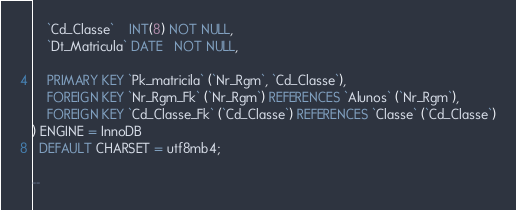<code> <loc_0><loc_0><loc_500><loc_500><_SQL_>    `Cd_Classe`    INT(8) NOT NULL,
    `Dt_Matricula` DATE   NOT NULL,

    PRIMARY KEY `Pk_matricila` (`Nr_Rgm`, `Cd_Classe`),
    FOREIGN KEY `Nr_Rgm_Fk` (`Nr_Rgm`) REFERENCES `Alunos` (`Nr_Rgm`),
    FOREIGN KEY `Cd_Classe_Fk` (`Cd_Classe`) REFERENCES `Classe` (`Cd_Classe`)
) ENGINE = InnoDB
  DEFAULT CHARSET = utf8mb4;

--


</code> 